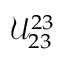<formula> <loc_0><loc_0><loc_500><loc_500>\mathcal { U } _ { 2 3 } ^ { 2 3 }</formula> 